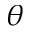Convert formula to latex. <formula><loc_0><loc_0><loc_500><loc_500>\theta</formula> 